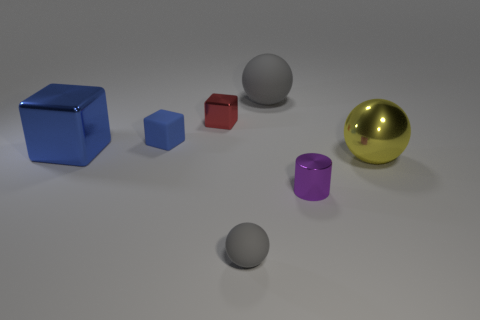How do the textures of the shiny objects compare to the matte ones? The shiny objects, such as the golden sphere and the purple cylinder, have a reflective surface that creates highlights and mirrors the environment, while the matte objects have more diffused light, showing less reflection and more consistent coloring. 